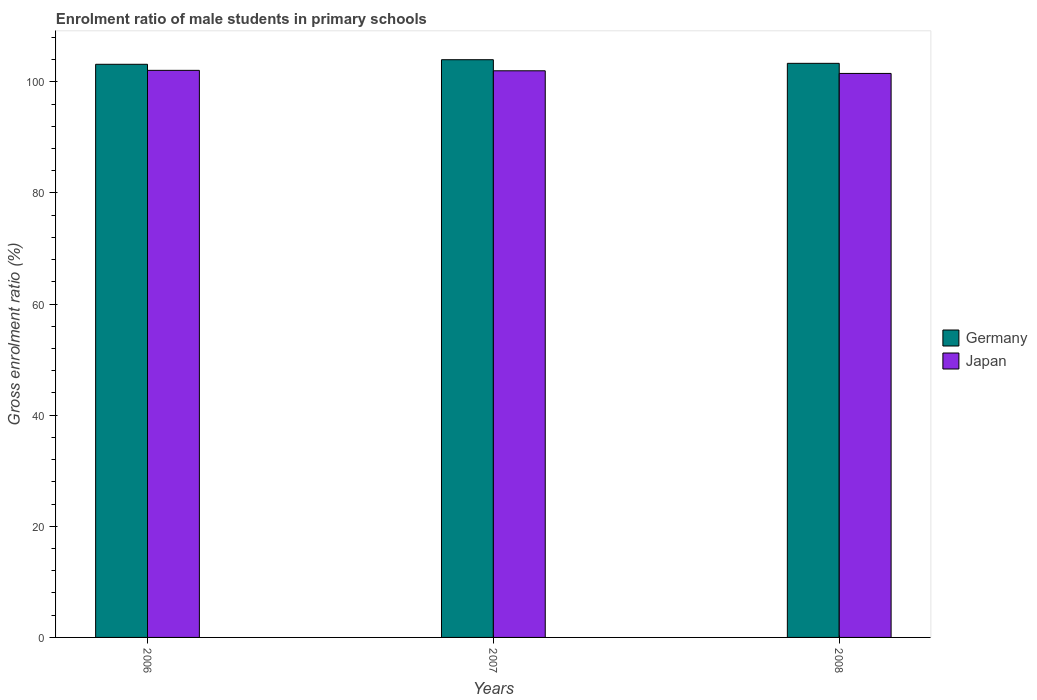How many different coloured bars are there?
Provide a succinct answer. 2. How many groups of bars are there?
Provide a succinct answer. 3. How many bars are there on the 3rd tick from the left?
Provide a succinct answer. 2. How many bars are there on the 1st tick from the right?
Make the answer very short. 2. What is the enrolment ratio of male students in primary schools in Germany in 2008?
Your response must be concise. 103.33. Across all years, what is the maximum enrolment ratio of male students in primary schools in Japan?
Provide a succinct answer. 102.07. Across all years, what is the minimum enrolment ratio of male students in primary schools in Germany?
Offer a terse response. 103.16. In which year was the enrolment ratio of male students in primary schools in Japan maximum?
Provide a short and direct response. 2006. What is the total enrolment ratio of male students in primary schools in Japan in the graph?
Your answer should be very brief. 305.57. What is the difference between the enrolment ratio of male students in primary schools in Germany in 2007 and that in 2008?
Offer a very short reply. 0.65. What is the difference between the enrolment ratio of male students in primary schools in Japan in 2007 and the enrolment ratio of male students in primary schools in Germany in 2006?
Your answer should be compact. -1.17. What is the average enrolment ratio of male students in primary schools in Japan per year?
Offer a very short reply. 101.86. In the year 2008, what is the difference between the enrolment ratio of male students in primary schools in Germany and enrolment ratio of male students in primary schools in Japan?
Provide a succinct answer. 1.81. What is the ratio of the enrolment ratio of male students in primary schools in Germany in 2006 to that in 2008?
Provide a succinct answer. 1. Is the enrolment ratio of male students in primary schools in Germany in 2006 less than that in 2007?
Ensure brevity in your answer.  Yes. Is the difference between the enrolment ratio of male students in primary schools in Germany in 2006 and 2008 greater than the difference between the enrolment ratio of male students in primary schools in Japan in 2006 and 2008?
Provide a succinct answer. No. What is the difference between the highest and the second highest enrolment ratio of male students in primary schools in Japan?
Keep it short and to the point. 0.08. What is the difference between the highest and the lowest enrolment ratio of male students in primary schools in Germany?
Your answer should be very brief. 0.82. In how many years, is the enrolment ratio of male students in primary schools in Germany greater than the average enrolment ratio of male students in primary schools in Germany taken over all years?
Provide a short and direct response. 1. What does the 2nd bar from the right in 2008 represents?
Give a very brief answer. Germany. How many bars are there?
Ensure brevity in your answer.  6. How many years are there in the graph?
Your response must be concise. 3. Does the graph contain any zero values?
Keep it short and to the point. No. Does the graph contain grids?
Make the answer very short. No. What is the title of the graph?
Your response must be concise. Enrolment ratio of male students in primary schools. What is the label or title of the X-axis?
Ensure brevity in your answer.  Years. What is the Gross enrolment ratio (%) in Germany in 2006?
Provide a succinct answer. 103.16. What is the Gross enrolment ratio (%) of Japan in 2006?
Your response must be concise. 102.07. What is the Gross enrolment ratio (%) of Germany in 2007?
Keep it short and to the point. 103.98. What is the Gross enrolment ratio (%) in Japan in 2007?
Keep it short and to the point. 101.99. What is the Gross enrolment ratio (%) in Germany in 2008?
Your answer should be compact. 103.33. What is the Gross enrolment ratio (%) in Japan in 2008?
Provide a short and direct response. 101.51. Across all years, what is the maximum Gross enrolment ratio (%) of Germany?
Give a very brief answer. 103.98. Across all years, what is the maximum Gross enrolment ratio (%) in Japan?
Offer a very short reply. 102.07. Across all years, what is the minimum Gross enrolment ratio (%) of Germany?
Keep it short and to the point. 103.16. Across all years, what is the minimum Gross enrolment ratio (%) in Japan?
Offer a very short reply. 101.51. What is the total Gross enrolment ratio (%) of Germany in the graph?
Offer a very short reply. 310.47. What is the total Gross enrolment ratio (%) in Japan in the graph?
Provide a short and direct response. 305.57. What is the difference between the Gross enrolment ratio (%) in Germany in 2006 and that in 2007?
Provide a succinct answer. -0.82. What is the difference between the Gross enrolment ratio (%) of Japan in 2006 and that in 2007?
Provide a succinct answer. 0.08. What is the difference between the Gross enrolment ratio (%) of Germany in 2006 and that in 2008?
Your response must be concise. -0.17. What is the difference between the Gross enrolment ratio (%) in Japan in 2006 and that in 2008?
Your answer should be compact. 0.55. What is the difference between the Gross enrolment ratio (%) in Germany in 2007 and that in 2008?
Offer a terse response. 0.65. What is the difference between the Gross enrolment ratio (%) in Japan in 2007 and that in 2008?
Offer a very short reply. 0.47. What is the difference between the Gross enrolment ratio (%) in Germany in 2006 and the Gross enrolment ratio (%) in Japan in 2007?
Make the answer very short. 1.17. What is the difference between the Gross enrolment ratio (%) in Germany in 2006 and the Gross enrolment ratio (%) in Japan in 2008?
Provide a succinct answer. 1.64. What is the difference between the Gross enrolment ratio (%) of Germany in 2007 and the Gross enrolment ratio (%) of Japan in 2008?
Your response must be concise. 2.47. What is the average Gross enrolment ratio (%) of Germany per year?
Keep it short and to the point. 103.49. What is the average Gross enrolment ratio (%) in Japan per year?
Make the answer very short. 101.86. In the year 2006, what is the difference between the Gross enrolment ratio (%) in Germany and Gross enrolment ratio (%) in Japan?
Provide a short and direct response. 1.09. In the year 2007, what is the difference between the Gross enrolment ratio (%) in Germany and Gross enrolment ratio (%) in Japan?
Give a very brief answer. 1.99. In the year 2008, what is the difference between the Gross enrolment ratio (%) in Germany and Gross enrolment ratio (%) in Japan?
Offer a very short reply. 1.81. What is the ratio of the Gross enrolment ratio (%) of Germany in 2006 to that in 2007?
Offer a terse response. 0.99. What is the ratio of the Gross enrolment ratio (%) of Germany in 2006 to that in 2008?
Keep it short and to the point. 1. What is the ratio of the Gross enrolment ratio (%) of Japan in 2006 to that in 2008?
Make the answer very short. 1.01. What is the ratio of the Gross enrolment ratio (%) of Germany in 2007 to that in 2008?
Keep it short and to the point. 1.01. What is the difference between the highest and the second highest Gross enrolment ratio (%) in Germany?
Offer a very short reply. 0.65. What is the difference between the highest and the second highest Gross enrolment ratio (%) in Japan?
Your answer should be compact. 0.08. What is the difference between the highest and the lowest Gross enrolment ratio (%) in Germany?
Offer a terse response. 0.82. What is the difference between the highest and the lowest Gross enrolment ratio (%) in Japan?
Your answer should be compact. 0.55. 